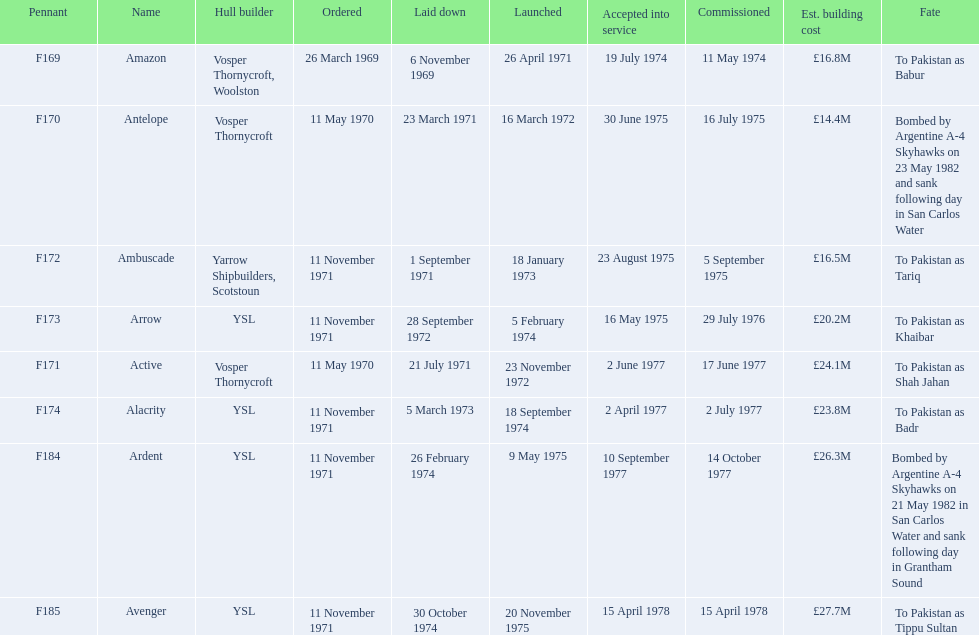What were the predicted building expenses for the frigates? £16.8M, £14.4M, £16.5M, £20.2M, £24.1M, £23.8M, £26.3M, £27.7M. Which among them is the biggest? £27.7M. What is the corresponding ship name? Avenger. Parse the table in full. {'header': ['Pennant', 'Name', 'Hull builder', 'Ordered', 'Laid down', 'Launched', 'Accepted into service', 'Commissioned', 'Est. building cost', 'Fate'], 'rows': [['F169', 'Amazon', 'Vosper Thornycroft, Woolston', '26 March 1969', '6 November 1969', '26 April 1971', '19 July 1974', '11 May 1974', '£16.8M', 'To Pakistan as Babur'], ['F170', 'Antelope', 'Vosper Thornycroft', '11 May 1970', '23 March 1971', '16 March 1972', '30 June 1975', '16 July 1975', '£14.4M', 'Bombed by Argentine A-4 Skyhawks on 23 May 1982 and sank following day in San Carlos Water'], ['F172', 'Ambuscade', 'Yarrow Shipbuilders, Scotstoun', '11 November 1971', '1 September 1971', '18 January 1973', '23 August 1975', '5 September 1975', '£16.5M', 'To Pakistan as Tariq'], ['F173', 'Arrow', 'YSL', '11 November 1971', '28 September 1972', '5 February 1974', '16 May 1975', '29 July 1976', '£20.2M', 'To Pakistan as Khaibar'], ['F171', 'Active', 'Vosper Thornycroft', '11 May 1970', '21 July 1971', '23 November 1972', '2 June 1977', '17 June 1977', '£24.1M', 'To Pakistan as Shah Jahan'], ['F174', 'Alacrity', 'YSL', '11 November 1971', '5 March 1973', '18 September 1974', '2 April 1977', '2 July 1977', '£23.8M', 'To Pakistan as Badr'], ['F184', 'Ardent', 'YSL', '11 November 1971', '26 February 1974', '9 May 1975', '10 September 1977', '14 October 1977', '£26.3M', 'Bombed by Argentine A-4 Skyhawks on 21 May 1982 in San Carlos Water and sank following day in Grantham Sound'], ['F185', 'Avenger', 'YSL', '11 November 1971', '30 October 1974', '20 November 1975', '15 April 1978', '15 April 1978', '£27.7M', 'To Pakistan as Tippu Sultan']]} 